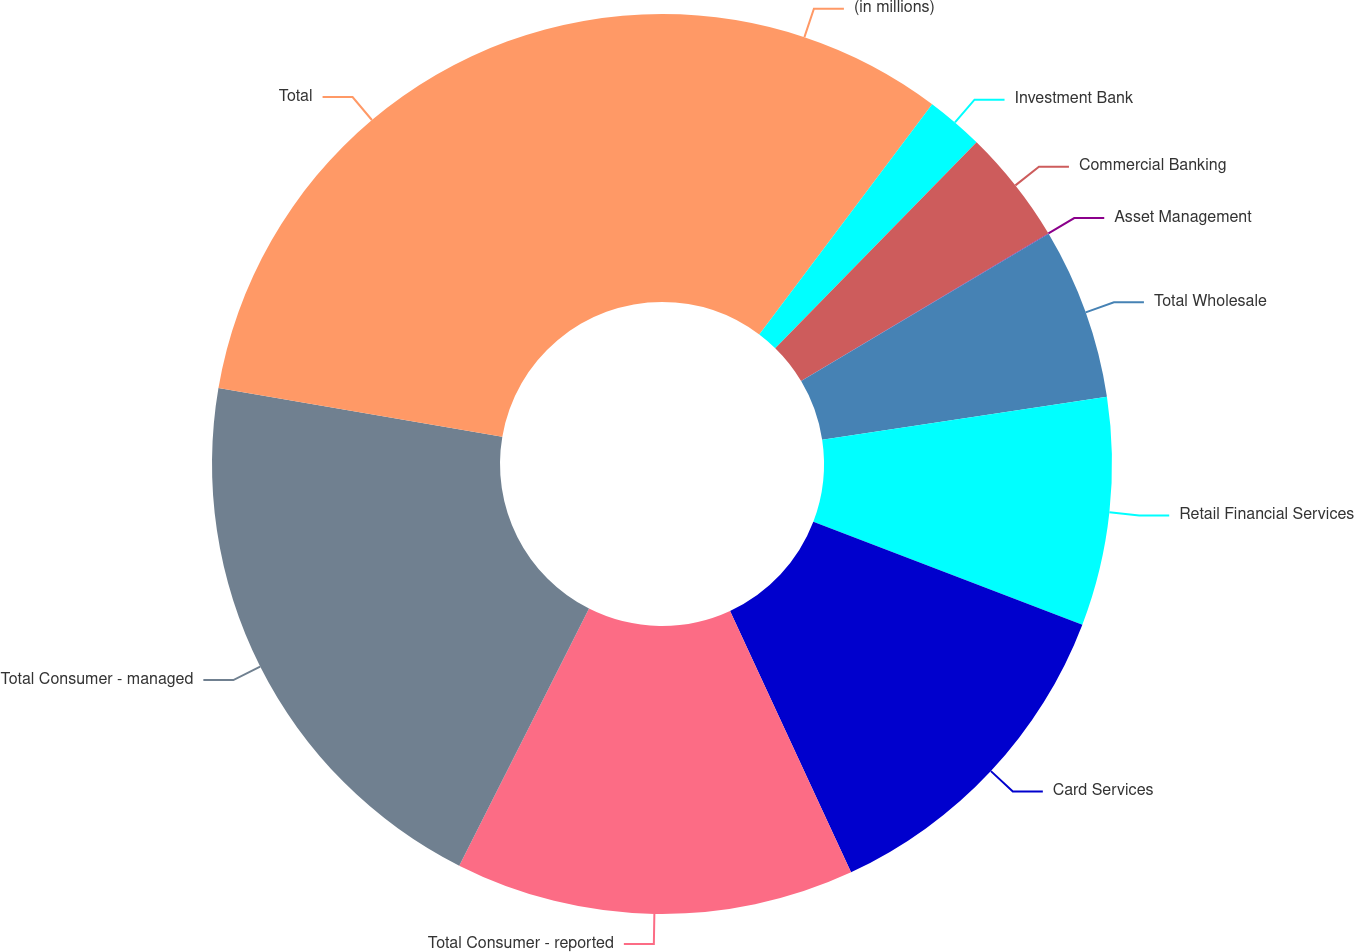Convert chart to OTSL. <chart><loc_0><loc_0><loc_500><loc_500><pie_chart><fcel>(in millions)<fcel>Investment Bank<fcel>Commercial Banking<fcel>Asset Management<fcel>Total Wholesale<fcel>Retail Financial Services<fcel>Card Services<fcel>Total Consumer - reported<fcel>Total Consumer - managed<fcel>Total<nl><fcel>10.25%<fcel>2.07%<fcel>4.11%<fcel>0.02%<fcel>6.16%<fcel>8.2%<fcel>12.29%<fcel>14.34%<fcel>20.26%<fcel>22.3%<nl></chart> 